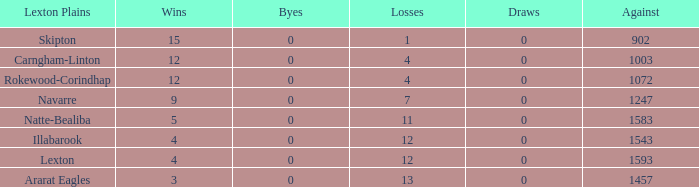What is the most wins with 0 byes? None. 